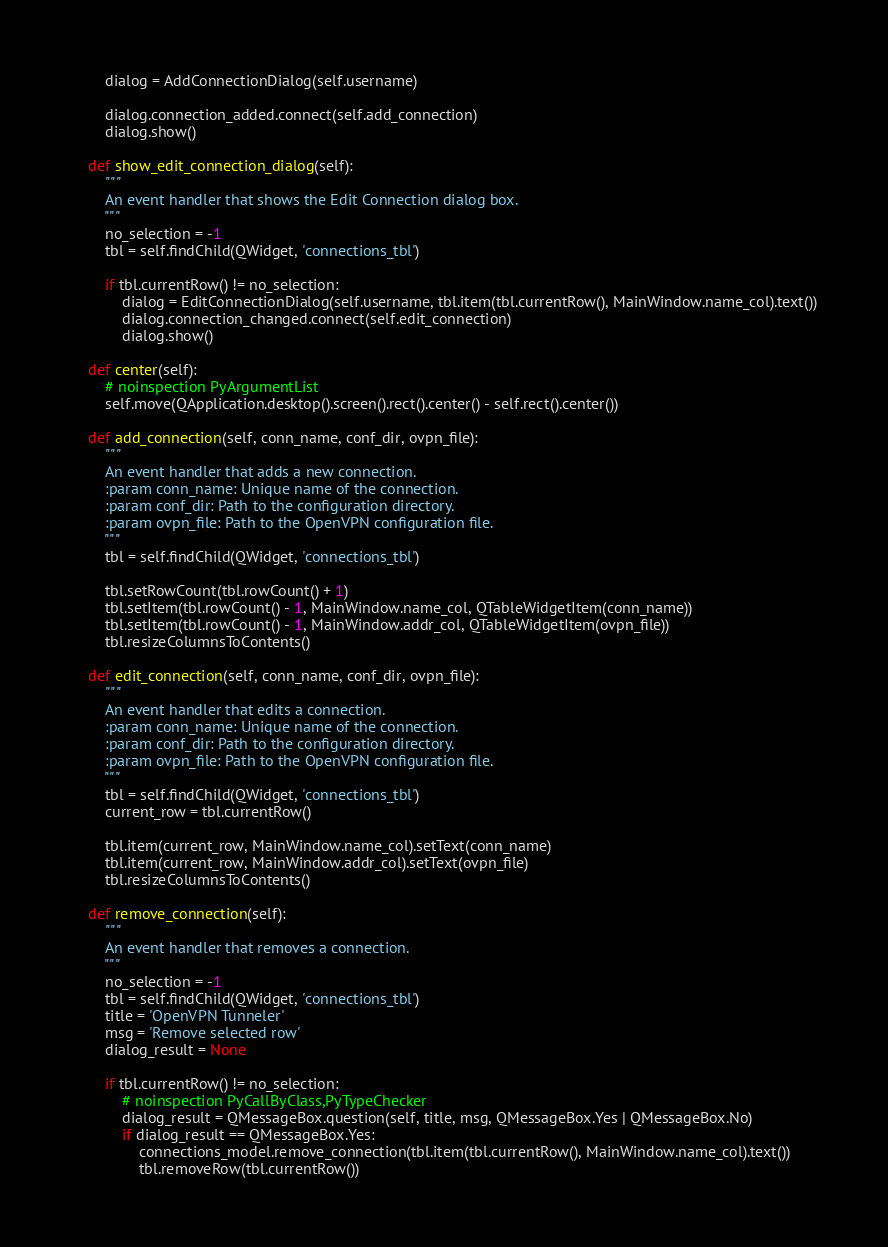Convert code to text. <code><loc_0><loc_0><loc_500><loc_500><_Python_>        dialog = AddConnectionDialog(self.username)

        dialog.connection_added.connect(self.add_connection)
        dialog.show()

    def show_edit_connection_dialog(self):
        """
        An event handler that shows the Edit Connection dialog box.
        """
        no_selection = -1
        tbl = self.findChild(QWidget, 'connections_tbl')

        if tbl.currentRow() != no_selection:
            dialog = EditConnectionDialog(self.username, tbl.item(tbl.currentRow(), MainWindow.name_col).text())
            dialog.connection_changed.connect(self.edit_connection)
            dialog.show()

    def center(self):
        # noinspection PyArgumentList
        self.move(QApplication.desktop().screen().rect().center() - self.rect().center())

    def add_connection(self, conn_name, conf_dir, ovpn_file):
        """
        An event handler that adds a new connection.
        :param conn_name: Unique name of the connection.
        :param conf_dir: Path to the configuration directory.
        :param ovpn_file: Path to the OpenVPN configuration file.
        """
        tbl = self.findChild(QWidget, 'connections_tbl')

        tbl.setRowCount(tbl.rowCount() + 1)
        tbl.setItem(tbl.rowCount() - 1, MainWindow.name_col, QTableWidgetItem(conn_name))
        tbl.setItem(tbl.rowCount() - 1, MainWindow.addr_col, QTableWidgetItem(ovpn_file))
        tbl.resizeColumnsToContents()

    def edit_connection(self, conn_name, conf_dir, ovpn_file):
        """
        An event handler that edits a connection.
        :param conn_name: Unique name of the connection.
        :param conf_dir: Path to the configuration directory.
        :param ovpn_file: Path to the OpenVPN configuration file.
        """
        tbl = self.findChild(QWidget, 'connections_tbl')
        current_row = tbl.currentRow()

        tbl.item(current_row, MainWindow.name_col).setText(conn_name)
        tbl.item(current_row, MainWindow.addr_col).setText(ovpn_file)
        tbl.resizeColumnsToContents()

    def remove_connection(self):
        """
        An event handler that removes a connection.
        """
        no_selection = -1
        tbl = self.findChild(QWidget, 'connections_tbl')
        title = 'OpenVPN Tunneler'
        msg = 'Remove selected row'
        dialog_result = None

        if tbl.currentRow() != no_selection:
            # noinspection PyCallByClass,PyTypeChecker
            dialog_result = QMessageBox.question(self, title, msg, QMessageBox.Yes | QMessageBox.No)
            if dialog_result == QMessageBox.Yes:
                connections_model.remove_connection(tbl.item(tbl.currentRow(), MainWindow.name_col).text())
                tbl.removeRow(tbl.currentRow())
</code> 